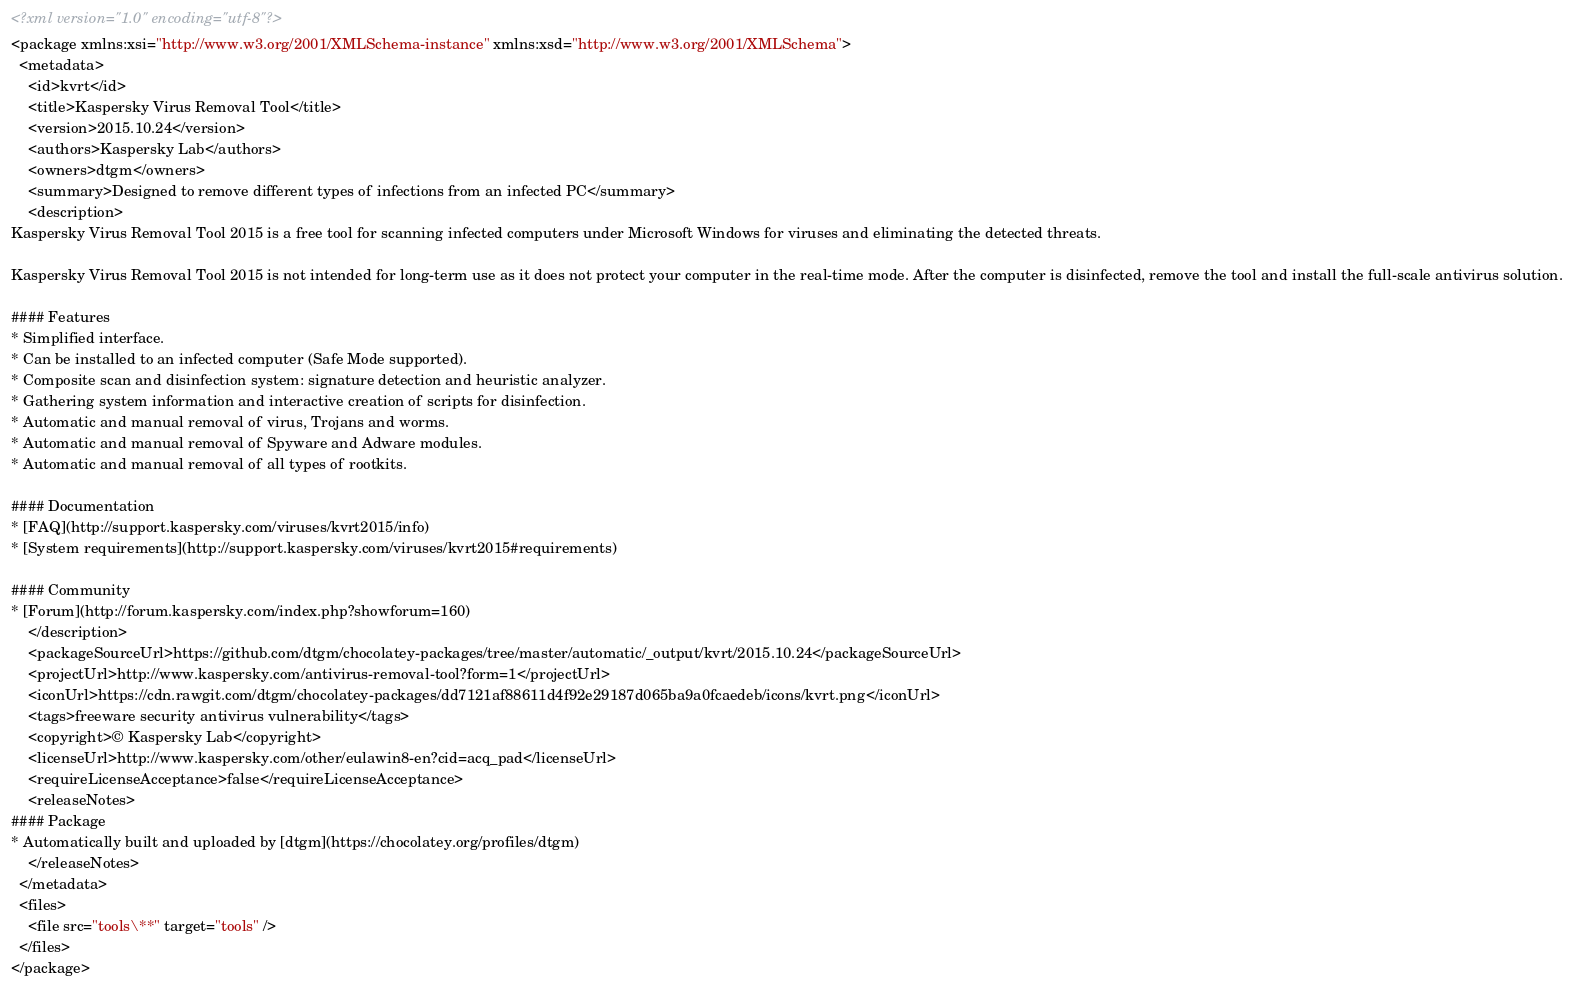<code> <loc_0><loc_0><loc_500><loc_500><_XML_><?xml version="1.0" encoding="utf-8"?>
<package xmlns:xsi="http://www.w3.org/2001/XMLSchema-instance" xmlns:xsd="http://www.w3.org/2001/XMLSchema">
  <metadata>
    <id>kvrt</id>
    <title>Kaspersky Virus Removal Tool</title>
    <version>2015.10.24</version>
    <authors>Kaspersky Lab</authors>
    <owners>dtgm</owners>
    <summary>Designed to remove different types of infections from an infected PC</summary>
    <description>
Kaspersky Virus Removal Tool 2015 is a free tool for scanning infected computers under Microsoft Windows for viruses and eliminating the detected threats.

Kaspersky Virus Removal Tool 2015 is not intended for long-term use as it does not protect your computer in the real-time mode. After the computer is disinfected, remove the tool and install the full-scale antivirus solution.

#### Features			
* Simplified interface.
* Can be installed to an infected computer (Safe Mode supported).
* Composite scan and disinfection system: signature detection and heuristic analyzer.
* Gathering system information and interactive creation of scripts for disinfection.
* Automatic and manual removal of virus, Trojans and worms.
* Automatic and manual removal of Spyware and Adware modules.
* Automatic and manual removal of all types of rootkits.

#### Documentation
* [FAQ](http://support.kaspersky.com/viruses/kvrt2015/info)
* [System requirements](http://support.kaspersky.com/viruses/kvrt2015#requirements)

#### Community
* [Forum](http://forum.kaspersky.com/index.php?showforum=160)
    </description>
    <packageSourceUrl>https://github.com/dtgm/chocolatey-packages/tree/master/automatic/_output/kvrt/2015.10.24</packageSourceUrl>
    <projectUrl>http://www.kaspersky.com/antivirus-removal-tool?form=1</projectUrl>
    <iconUrl>https://cdn.rawgit.com/dtgm/chocolatey-packages/dd7121af88611d4f92e29187d065ba9a0fcaedeb/icons/kvrt.png</iconUrl>
    <tags>freeware security antivirus vulnerability</tags>
    <copyright>© Kaspersky Lab</copyright>
    <licenseUrl>http://www.kaspersky.com/other/eulawin8-en?cid=acq_pad</licenseUrl>
    <requireLicenseAcceptance>false</requireLicenseAcceptance>
    <releaseNotes>
#### Package
* Automatically built and uploaded by [dtgm](https://chocolatey.org/profiles/dtgm)
    </releaseNotes>
  </metadata>
  <files>
    <file src="tools\**" target="tools" />
  </files>
</package></code> 